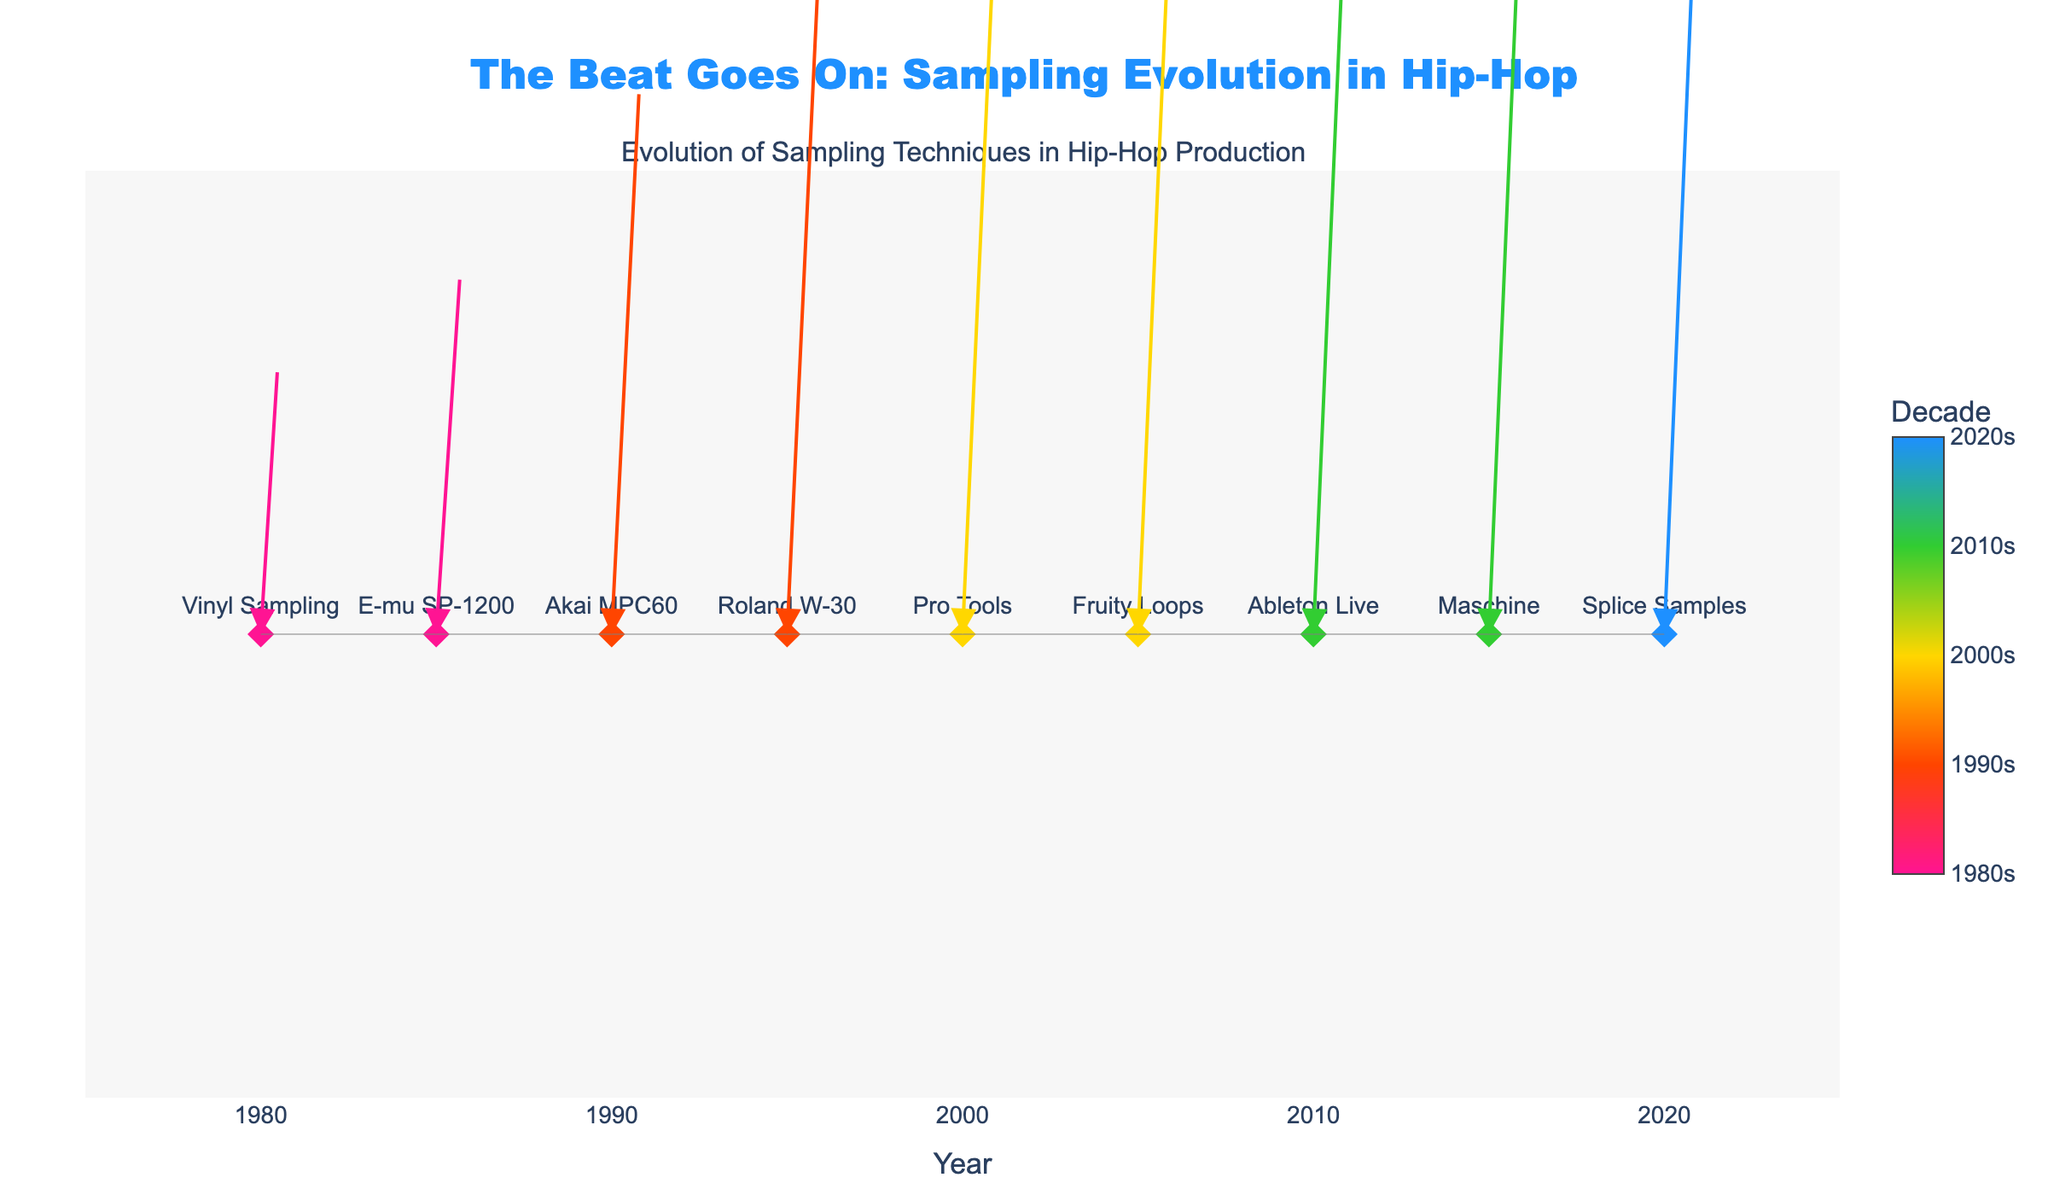What is the title of the figure? The title is usually located at the top of the figure. In this case, the title is "The Beat Goes On: Sampling Evolution in Hip-Hop", which summarizes what the plot is about.
Answer: The Beat Goes On: Sampling Evolution in Hip-Hop What decades are covered in this figure? The plot's color bar shows the decades, which include the 1980s, 1990s, 2000s, 2010s, and 2020s. These labels are found beside the color scale legend.
Answer: 1980s, 1990s, 2000s, 2010s, 2020s How many distinct sampling techniques are represented in the figure? Each sampling technique is shown as a data point, labeled with the technique name. By counting these labels, we find that there are nine distinct techniques represented.
Answer: Nine Which sampling technique was prominent in the 2000s? The marker colors and the corresponding color bar represent different decades. By identifying the markers associated with the 2000s color scale, we find the techniques Pro Tools and Fruity Loops.
Answer: Pro Tools, Fruity Loops Which sampling technique has the largest horizontal and vertical arrows? The length of the arrows represents the magnitudes of U and V components. By visually inspecting the arrows, the largest in both directions is associated with Splice Samples.
Answer: Splice Samples How do the techniques from the 1980s compare to those from the 2010s in terms of arrow direction and length? The techniques from the 1980s (Vinyl Sampling, E-mu SP-1200) are identified by their shorter arrows both horizontally and vertically while the techniques from the 2010s (Ableton Live, Maschine) have longer arrows, indicating greater changes in sampling technology.
Answer: 1980s arrows are shorter; 2010s arrows are longer Which decade shows the most significant shift in sampling technology? By comparing arrows of different decades, it appears the 2020s, represented by Splice Samples, has the longest arrows in both U and V dimensions, indicating the most significant shift.
Answer: 2020s Which sampling techniques introduced after 2000? Referring to the color scale, techniques appearing in the colors for 2000s, 2010s, and 2020s are Pro Tools, Fruity Loops, Ableton Live, Maschine, and Splice Samples.
Answer: Pro Tools, Fruity Loops, Ableton Live, Maschine, Splice Samples 